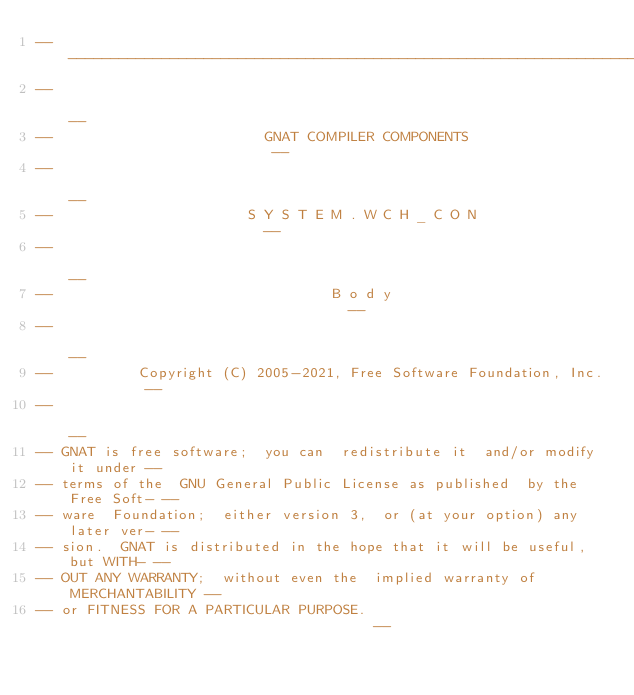<code> <loc_0><loc_0><loc_500><loc_500><_Ada_>------------------------------------------------------------------------------
--                                                                          --
--                         GNAT COMPILER COMPONENTS                         --
--                                                                          --
--                       S Y S T E M . W C H _ C O N                        --
--                                                                          --
--                                 B o d y                                  --
--                                                                          --
--          Copyright (C) 2005-2021, Free Software Foundation, Inc.         --
--                                                                          --
-- GNAT is free software;  you can  redistribute it  and/or modify it under --
-- terms of the  GNU General Public License as published  by the Free Soft- --
-- ware  Foundation;  either version 3,  or (at your option) any later ver- --
-- sion.  GNAT is distributed in the hope that it will be useful, but WITH- --
-- OUT ANY WARRANTY;  without even the  implied warranty of MERCHANTABILITY --
-- or FITNESS FOR A PARTICULAR PURPOSE.                                     --</code> 